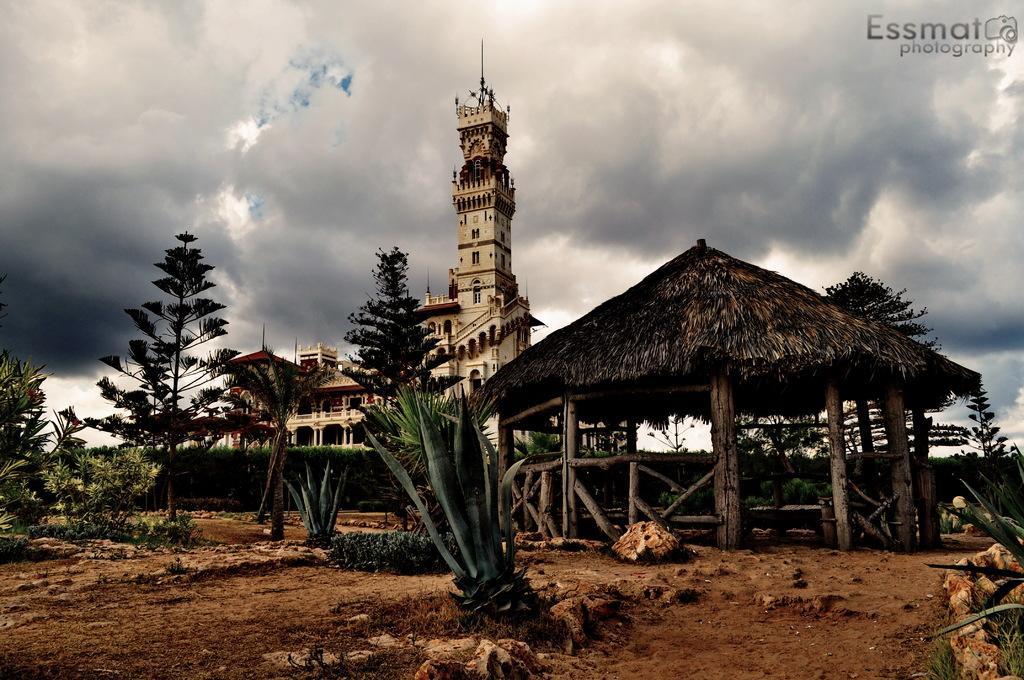Could you give a brief overview of what you see in this image? This image is taken outdoors. At the top of the image there is a sky with clouds. At the bottom of the image there is a ground with a few stones on it. In the background there is a building and a tower with walls, windows, carvings, architectures, stairs, railings, pillars, roofs and doors. There are many plants and a few trees on the ground. In the middle of the image there is a hut with a few wooden sticks and there are a few plants. 